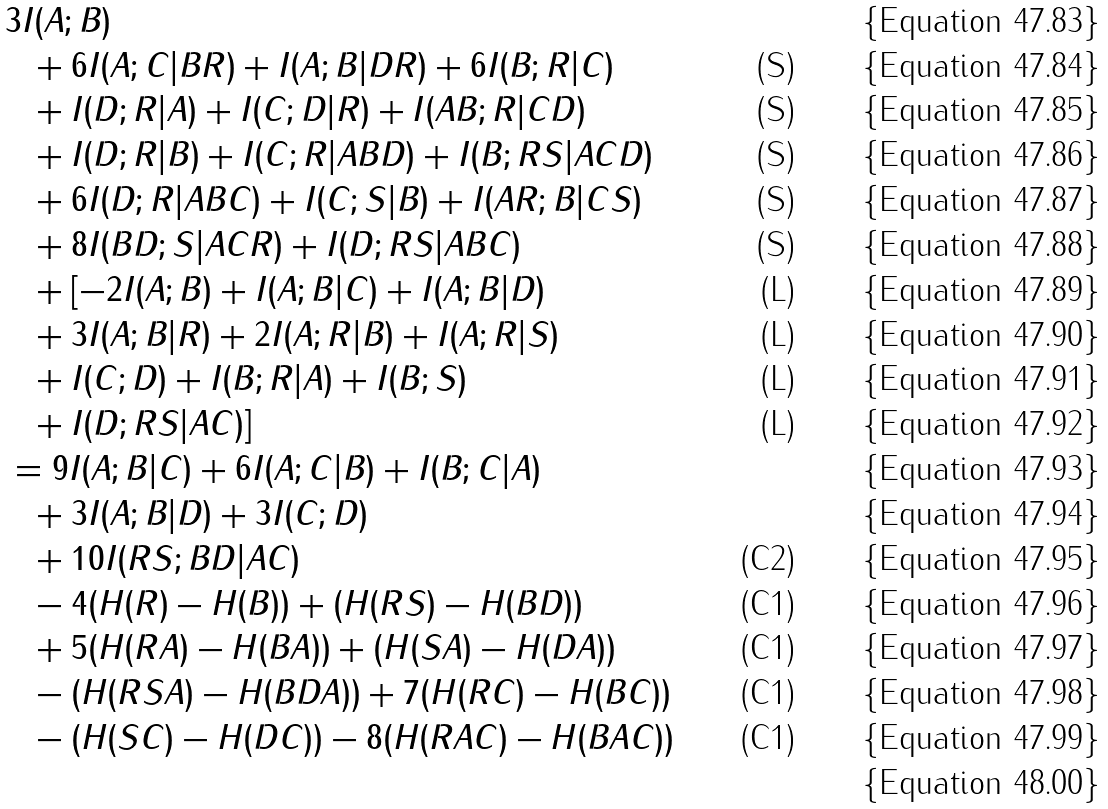<formula> <loc_0><loc_0><loc_500><loc_500>& 3 I ( A ; B ) & \\ & \ \ + 6 I ( A ; C | B R ) + I ( A ; B | D R ) + 6 I ( B ; R | C ) & \text {(S)} \\ & \ \ + I ( D ; R | A ) + I ( C ; D | R ) + I ( A B ; R | C D ) & \text {(S)} \\ & \ \ + I ( D ; R | B ) + I ( C ; R | A B D ) + I ( B ; R S | A C D ) & \text {(S)} \\ & \ \ + 6 I ( D ; R | A B C ) + I ( C ; S | B ) + I ( A R ; B | C S ) & \text {(S)} \\ & \ \ + 8 I ( B D ; S | A C R ) + I ( D ; R S | A B C ) & \text {(S)} \\ & \ \ + [ - 2 I ( A ; B ) + I ( A ; B | C ) + I ( A ; B | D ) & \text {(L)} \\ & \ \ + 3 I ( A ; B | R ) + 2 I ( A ; R | B ) + I ( A ; R | S ) & \text {(L)} \\ & \ \ + I ( C ; D ) + I ( B ; R | A ) + I ( B ; S ) & \text {(L)} \\ & \ \ + I ( D ; R S | A C ) ] & \text {(L)} \\ & = 9 I ( A ; B | C ) + 6 I ( A ; C | B ) + I ( B ; C | A ) \\ & \ \ + 3 I ( A ; B | D ) + 3 I ( C ; D ) \\ & \ \ + 1 0 I ( R S ; B D | A C ) & \text {(C2)} \\ & \ \ - 4 ( H ( R ) - H ( B ) ) + ( H ( R S ) - H ( B D ) ) & \text {(C1)} \\ & \ \ + 5 ( H ( R A ) - H ( B A ) ) + ( H ( S A ) - H ( D A ) ) & \text {(C1)} \\ & \ \ - ( H ( R S A ) - H ( B D A ) ) + 7 ( H ( R C ) - H ( B C ) ) & \text {(C1)} \\ & \ \ - ( H ( S C ) - H ( D C ) ) - 8 ( H ( R A C ) - H ( B A C ) ) & \text {(C1)} \\</formula> 